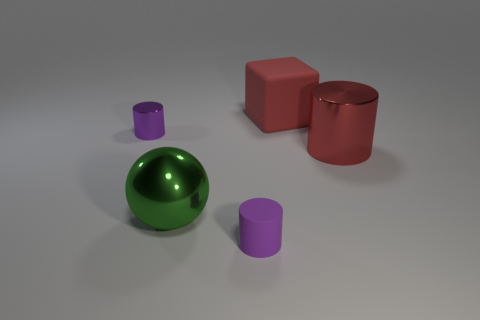Is the number of large red cylinders that are behind the tiny shiny cylinder greater than the number of cylinders right of the large red metallic object?
Provide a succinct answer. No. There is a small purple rubber object; are there any red metallic objects right of it?
Keep it short and to the point. Yes. Is there a rubber ball of the same size as the red cylinder?
Give a very brief answer. No. There is a tiny object that is made of the same material as the sphere; what is its color?
Your answer should be compact. Purple. What is the material of the green thing?
Offer a terse response. Metal. There is a purple metallic thing; what shape is it?
Offer a very short reply. Cylinder. How many metal spheres are the same color as the large metallic cylinder?
Provide a short and direct response. 0. The red object that is in front of the tiny cylinder that is behind the purple cylinder that is to the right of the big green metallic ball is made of what material?
Your answer should be very brief. Metal. What number of red things are cylinders or matte blocks?
Give a very brief answer. 2. What size is the rubber thing in front of the shiny cylinder that is left of the purple cylinder that is in front of the large cylinder?
Keep it short and to the point. Small. 